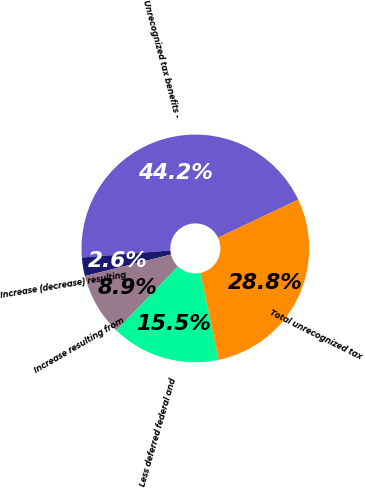<chart> <loc_0><loc_0><loc_500><loc_500><pie_chart><fcel>Unrecognized tax benefits -<fcel>Increase (decrease) resulting<fcel>Increase resulting from<fcel>Less deferred federal and<fcel>Total unrecognized tax<nl><fcel>44.25%<fcel>2.62%<fcel>8.89%<fcel>15.49%<fcel>28.76%<nl></chart> 